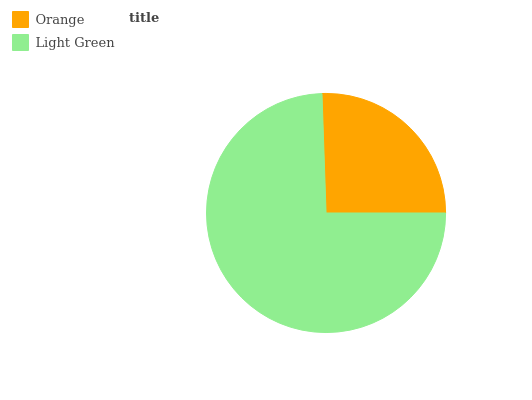Is Orange the minimum?
Answer yes or no. Yes. Is Light Green the maximum?
Answer yes or no. Yes. Is Light Green the minimum?
Answer yes or no. No. Is Light Green greater than Orange?
Answer yes or no. Yes. Is Orange less than Light Green?
Answer yes or no. Yes. Is Orange greater than Light Green?
Answer yes or no. No. Is Light Green less than Orange?
Answer yes or no. No. Is Light Green the high median?
Answer yes or no. Yes. Is Orange the low median?
Answer yes or no. Yes. Is Orange the high median?
Answer yes or no. No. Is Light Green the low median?
Answer yes or no. No. 